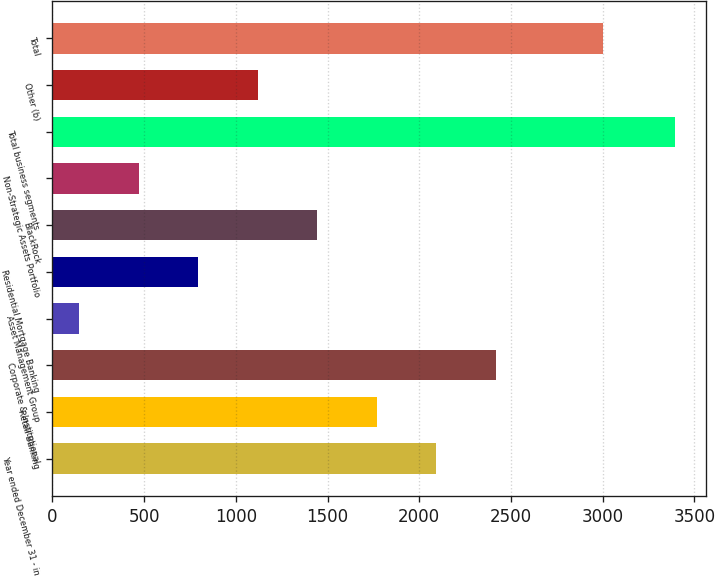<chart> <loc_0><loc_0><loc_500><loc_500><bar_chart><fcel>Year ended December 31 - in<fcel>Retail Banking<fcel>Corporate & Institutional<fcel>Asset Management Group<fcel>Residential Mortgage Banking<fcel>BlackRock<fcel>Non-Strategic Assets Portfolio<fcel>Total business segments<fcel>Other (b)<fcel>Total<nl><fcel>2093.8<fcel>1769<fcel>2418.6<fcel>145<fcel>794.6<fcel>1444.2<fcel>469.8<fcel>3393<fcel>1119.4<fcel>3001<nl></chart> 